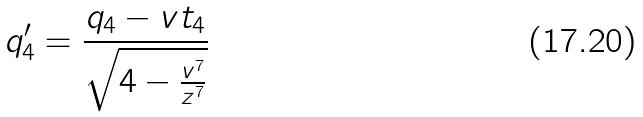Convert formula to latex. <formula><loc_0><loc_0><loc_500><loc_500>q _ { 4 } ^ { \prime } = \frac { q _ { 4 } - v t _ { 4 } } { \sqrt { 4 - \frac { v ^ { 7 } } { z ^ { 7 } } } }</formula> 